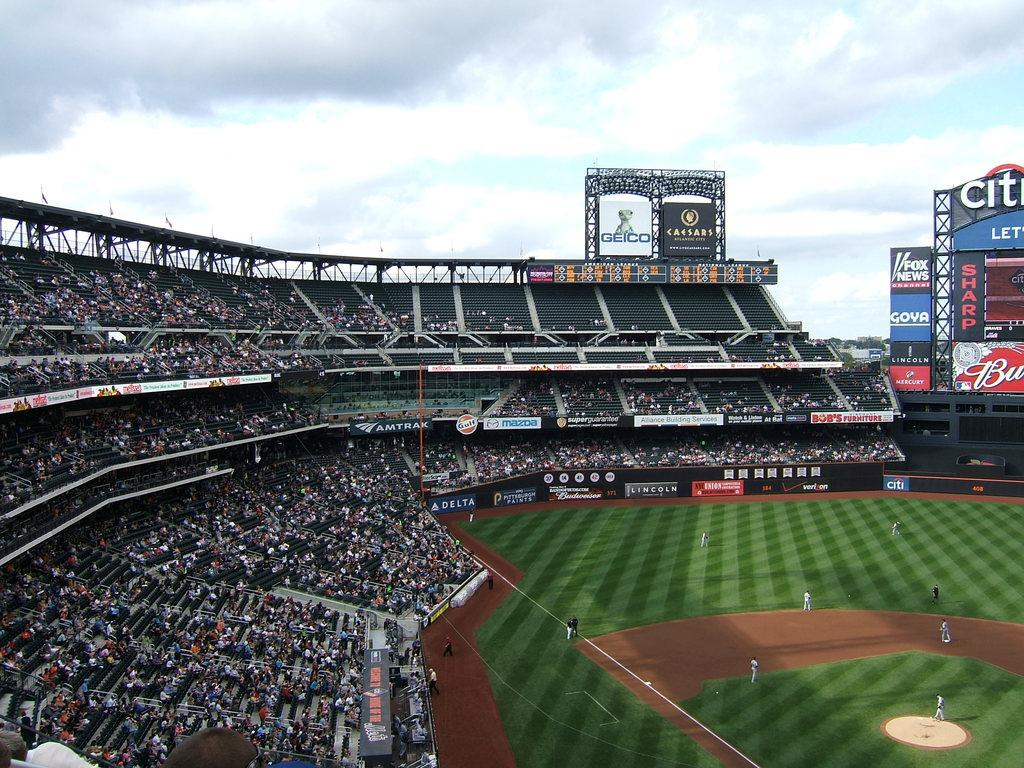<image>
Create a compact narrative representing the image presented. People are gathered in the stands watching baseball game at Citi Field. 